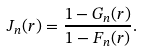<formula> <loc_0><loc_0><loc_500><loc_500>J _ { n } ( r ) = \frac { 1 - G _ { n } ( r ) } { 1 - F _ { n } ( r ) } .</formula> 